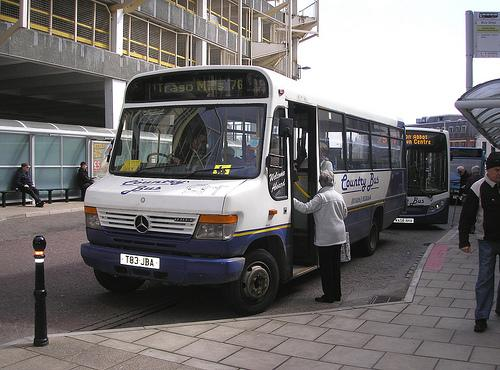How many people are in the image and what are their actions? There are four people present: a lady about to board the bus, a man about to enter the bus, a person sitting on a bench, and a man standing on the sidewalk wearing blue jeans. What mode of transportation is depicted in the image? A big blue and white bus is at a stop, with passengers about to board it. Briefly explain the sentiment evoked by the image. The image portrays an everyday, urban scene evoking a feeling of normalcy and routine as people go about their daily activities. Count and describe the objects found on the sidewalk. There are four objects on the sidewalk: a person sitting on a bench, a man standing, a black pole, and a short black post. 